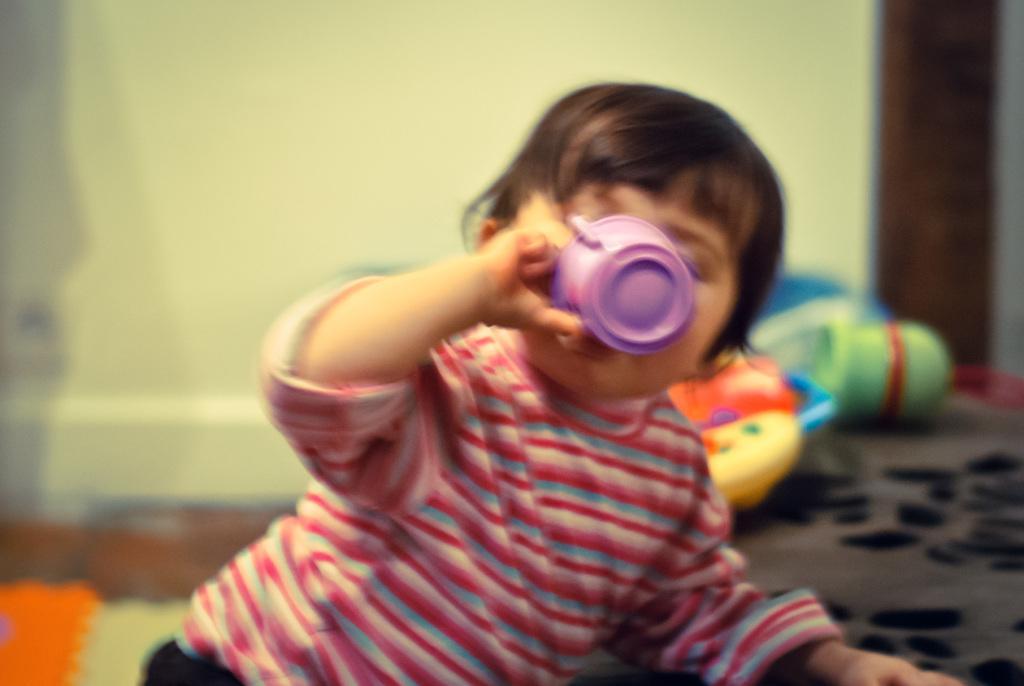In one or two sentences, can you explain what this image depicts? Here we can see a kid holding a cup with his hand. There are toys and there is a blur background. 